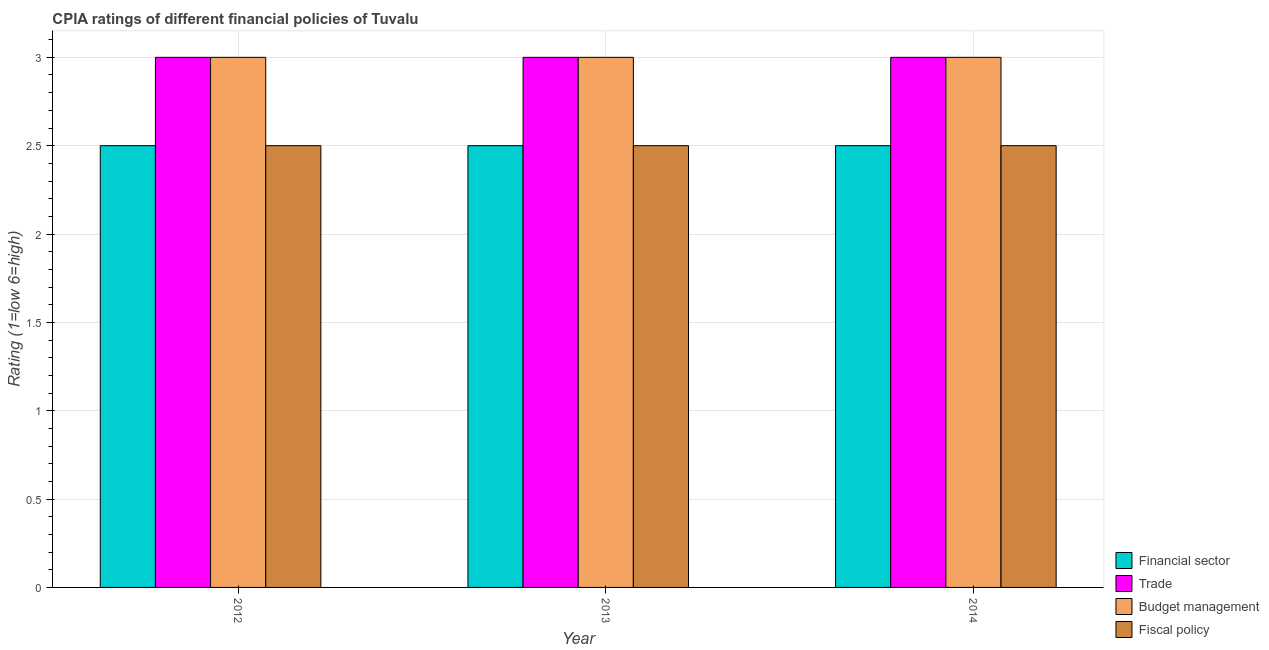How many different coloured bars are there?
Offer a terse response. 4. Are the number of bars on each tick of the X-axis equal?
Provide a short and direct response. Yes. How many bars are there on the 2nd tick from the right?
Provide a short and direct response. 4. What is the cpia rating of financial sector in 2014?
Provide a short and direct response. 2.5. Across all years, what is the maximum cpia rating of budget management?
Ensure brevity in your answer.  3. Across all years, what is the minimum cpia rating of budget management?
Your response must be concise. 3. In which year was the cpia rating of trade maximum?
Your answer should be compact. 2012. What is the total cpia rating of budget management in the graph?
Offer a very short reply. 9. What is the difference between the cpia rating of financial sector in 2012 and that in 2013?
Your answer should be very brief. 0. What is the difference between the cpia rating of financial sector in 2014 and the cpia rating of trade in 2012?
Your answer should be compact. 0. In the year 2013, what is the difference between the cpia rating of financial sector and cpia rating of trade?
Your response must be concise. 0. Is the sum of the cpia rating of fiscal policy in 2012 and 2014 greater than the maximum cpia rating of trade across all years?
Offer a terse response. Yes. Is it the case that in every year, the sum of the cpia rating of financial sector and cpia rating of fiscal policy is greater than the sum of cpia rating of budget management and cpia rating of trade?
Ensure brevity in your answer.  No. What does the 3rd bar from the left in 2014 represents?
Your answer should be very brief. Budget management. What does the 4th bar from the right in 2012 represents?
Provide a short and direct response. Financial sector. Is it the case that in every year, the sum of the cpia rating of financial sector and cpia rating of trade is greater than the cpia rating of budget management?
Provide a short and direct response. Yes. How many bars are there?
Your answer should be very brief. 12. Are all the bars in the graph horizontal?
Make the answer very short. No. What is the difference between two consecutive major ticks on the Y-axis?
Offer a terse response. 0.5. Are the values on the major ticks of Y-axis written in scientific E-notation?
Keep it short and to the point. No. Where does the legend appear in the graph?
Your answer should be compact. Bottom right. How are the legend labels stacked?
Make the answer very short. Vertical. What is the title of the graph?
Your answer should be compact. CPIA ratings of different financial policies of Tuvalu. What is the label or title of the X-axis?
Make the answer very short. Year. What is the Rating (1=low 6=high) of Financial sector in 2012?
Your response must be concise. 2.5. What is the Rating (1=low 6=high) in Budget management in 2012?
Your answer should be compact. 3. What is the Rating (1=low 6=high) in Budget management in 2013?
Give a very brief answer. 3. What is the Rating (1=low 6=high) of Financial sector in 2014?
Your answer should be compact. 2.5. What is the Rating (1=low 6=high) in Trade in 2014?
Provide a short and direct response. 3. What is the Rating (1=low 6=high) of Fiscal policy in 2014?
Your answer should be compact. 2.5. Across all years, what is the maximum Rating (1=low 6=high) in Financial sector?
Ensure brevity in your answer.  2.5. Across all years, what is the maximum Rating (1=low 6=high) of Trade?
Ensure brevity in your answer.  3. Across all years, what is the minimum Rating (1=low 6=high) of Financial sector?
Ensure brevity in your answer.  2.5. Across all years, what is the minimum Rating (1=low 6=high) of Trade?
Your answer should be compact. 3. Across all years, what is the minimum Rating (1=low 6=high) of Fiscal policy?
Provide a short and direct response. 2.5. What is the total Rating (1=low 6=high) in Financial sector in the graph?
Ensure brevity in your answer.  7.5. What is the total Rating (1=low 6=high) of Trade in the graph?
Your answer should be compact. 9. What is the total Rating (1=low 6=high) in Budget management in the graph?
Keep it short and to the point. 9. What is the difference between the Rating (1=low 6=high) in Fiscal policy in 2012 and that in 2013?
Provide a short and direct response. 0. What is the difference between the Rating (1=low 6=high) of Financial sector in 2012 and that in 2014?
Offer a very short reply. 0. What is the difference between the Rating (1=low 6=high) in Budget management in 2012 and that in 2014?
Your answer should be very brief. 0. What is the difference between the Rating (1=low 6=high) in Budget management in 2013 and that in 2014?
Keep it short and to the point. 0. What is the difference between the Rating (1=low 6=high) of Financial sector in 2012 and the Rating (1=low 6=high) of Budget management in 2013?
Make the answer very short. -0.5. What is the difference between the Rating (1=low 6=high) of Trade in 2012 and the Rating (1=low 6=high) of Fiscal policy in 2013?
Keep it short and to the point. 0.5. What is the difference between the Rating (1=low 6=high) in Budget management in 2012 and the Rating (1=low 6=high) in Fiscal policy in 2013?
Provide a succinct answer. 0.5. What is the difference between the Rating (1=low 6=high) in Financial sector in 2012 and the Rating (1=low 6=high) in Trade in 2014?
Keep it short and to the point. -0.5. What is the difference between the Rating (1=low 6=high) in Trade in 2012 and the Rating (1=low 6=high) in Fiscal policy in 2014?
Provide a succinct answer. 0.5. What is the difference between the Rating (1=low 6=high) of Financial sector in 2013 and the Rating (1=low 6=high) of Trade in 2014?
Give a very brief answer. -0.5. What is the difference between the Rating (1=low 6=high) in Financial sector in 2013 and the Rating (1=low 6=high) in Budget management in 2014?
Make the answer very short. -0.5. What is the difference between the Rating (1=low 6=high) of Trade in 2013 and the Rating (1=low 6=high) of Budget management in 2014?
Provide a short and direct response. 0. What is the difference between the Rating (1=low 6=high) in Trade in 2013 and the Rating (1=low 6=high) in Fiscal policy in 2014?
Your answer should be very brief. 0.5. What is the difference between the Rating (1=low 6=high) of Budget management in 2013 and the Rating (1=low 6=high) of Fiscal policy in 2014?
Offer a very short reply. 0.5. What is the average Rating (1=low 6=high) of Trade per year?
Your response must be concise. 3. What is the average Rating (1=low 6=high) in Fiscal policy per year?
Provide a succinct answer. 2.5. In the year 2012, what is the difference between the Rating (1=low 6=high) of Financial sector and Rating (1=low 6=high) of Trade?
Provide a succinct answer. -0.5. In the year 2012, what is the difference between the Rating (1=low 6=high) in Financial sector and Rating (1=low 6=high) in Budget management?
Your answer should be compact. -0.5. In the year 2012, what is the difference between the Rating (1=low 6=high) in Trade and Rating (1=low 6=high) in Fiscal policy?
Your answer should be compact. 0.5. In the year 2013, what is the difference between the Rating (1=low 6=high) of Financial sector and Rating (1=low 6=high) of Budget management?
Offer a terse response. -0.5. In the year 2013, what is the difference between the Rating (1=low 6=high) in Budget management and Rating (1=low 6=high) in Fiscal policy?
Your answer should be very brief. 0.5. In the year 2014, what is the difference between the Rating (1=low 6=high) of Financial sector and Rating (1=low 6=high) of Trade?
Provide a short and direct response. -0.5. In the year 2014, what is the difference between the Rating (1=low 6=high) in Trade and Rating (1=low 6=high) in Budget management?
Keep it short and to the point. 0. In the year 2014, what is the difference between the Rating (1=low 6=high) in Trade and Rating (1=low 6=high) in Fiscal policy?
Offer a very short reply. 0.5. What is the ratio of the Rating (1=low 6=high) of Trade in 2012 to that in 2013?
Provide a succinct answer. 1. What is the ratio of the Rating (1=low 6=high) in Financial sector in 2012 to that in 2014?
Ensure brevity in your answer.  1. What is the ratio of the Rating (1=low 6=high) in Trade in 2012 to that in 2014?
Ensure brevity in your answer.  1. What is the ratio of the Rating (1=low 6=high) in Trade in 2013 to that in 2014?
Provide a short and direct response. 1. What is the ratio of the Rating (1=low 6=high) in Budget management in 2013 to that in 2014?
Your response must be concise. 1. What is the ratio of the Rating (1=low 6=high) of Fiscal policy in 2013 to that in 2014?
Give a very brief answer. 1. What is the difference between the highest and the second highest Rating (1=low 6=high) in Budget management?
Make the answer very short. 0. 